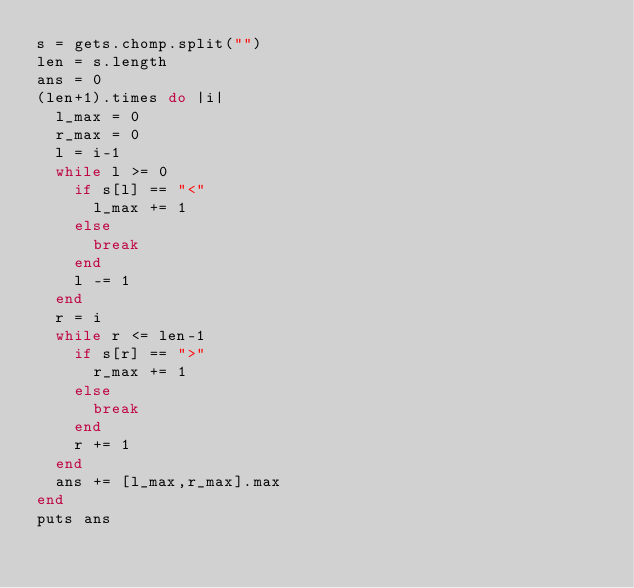<code> <loc_0><loc_0><loc_500><loc_500><_Ruby_>s = gets.chomp.split("")
len = s.length
ans = 0
(len+1).times do |i|
  l_max = 0
  r_max = 0
  l = i-1
  while l >= 0
    if s[l] == "<"
      l_max += 1
    else
      break
    end
    l -= 1
  end
  r = i
  while r <= len-1
    if s[r] == ">"
      r_max += 1
    else
      break
    end
    r += 1
  end
  ans += [l_max,r_max].max
end
puts ans</code> 